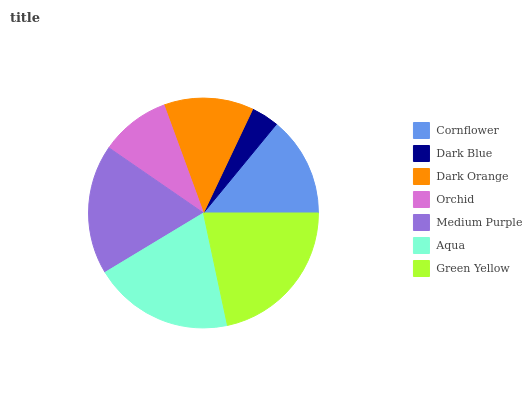Is Dark Blue the minimum?
Answer yes or no. Yes. Is Green Yellow the maximum?
Answer yes or no. Yes. Is Dark Orange the minimum?
Answer yes or no. No. Is Dark Orange the maximum?
Answer yes or no. No. Is Dark Orange greater than Dark Blue?
Answer yes or no. Yes. Is Dark Blue less than Dark Orange?
Answer yes or no. Yes. Is Dark Blue greater than Dark Orange?
Answer yes or no. No. Is Dark Orange less than Dark Blue?
Answer yes or no. No. Is Cornflower the high median?
Answer yes or no. Yes. Is Cornflower the low median?
Answer yes or no. Yes. Is Dark Orange the high median?
Answer yes or no. No. Is Aqua the low median?
Answer yes or no. No. 